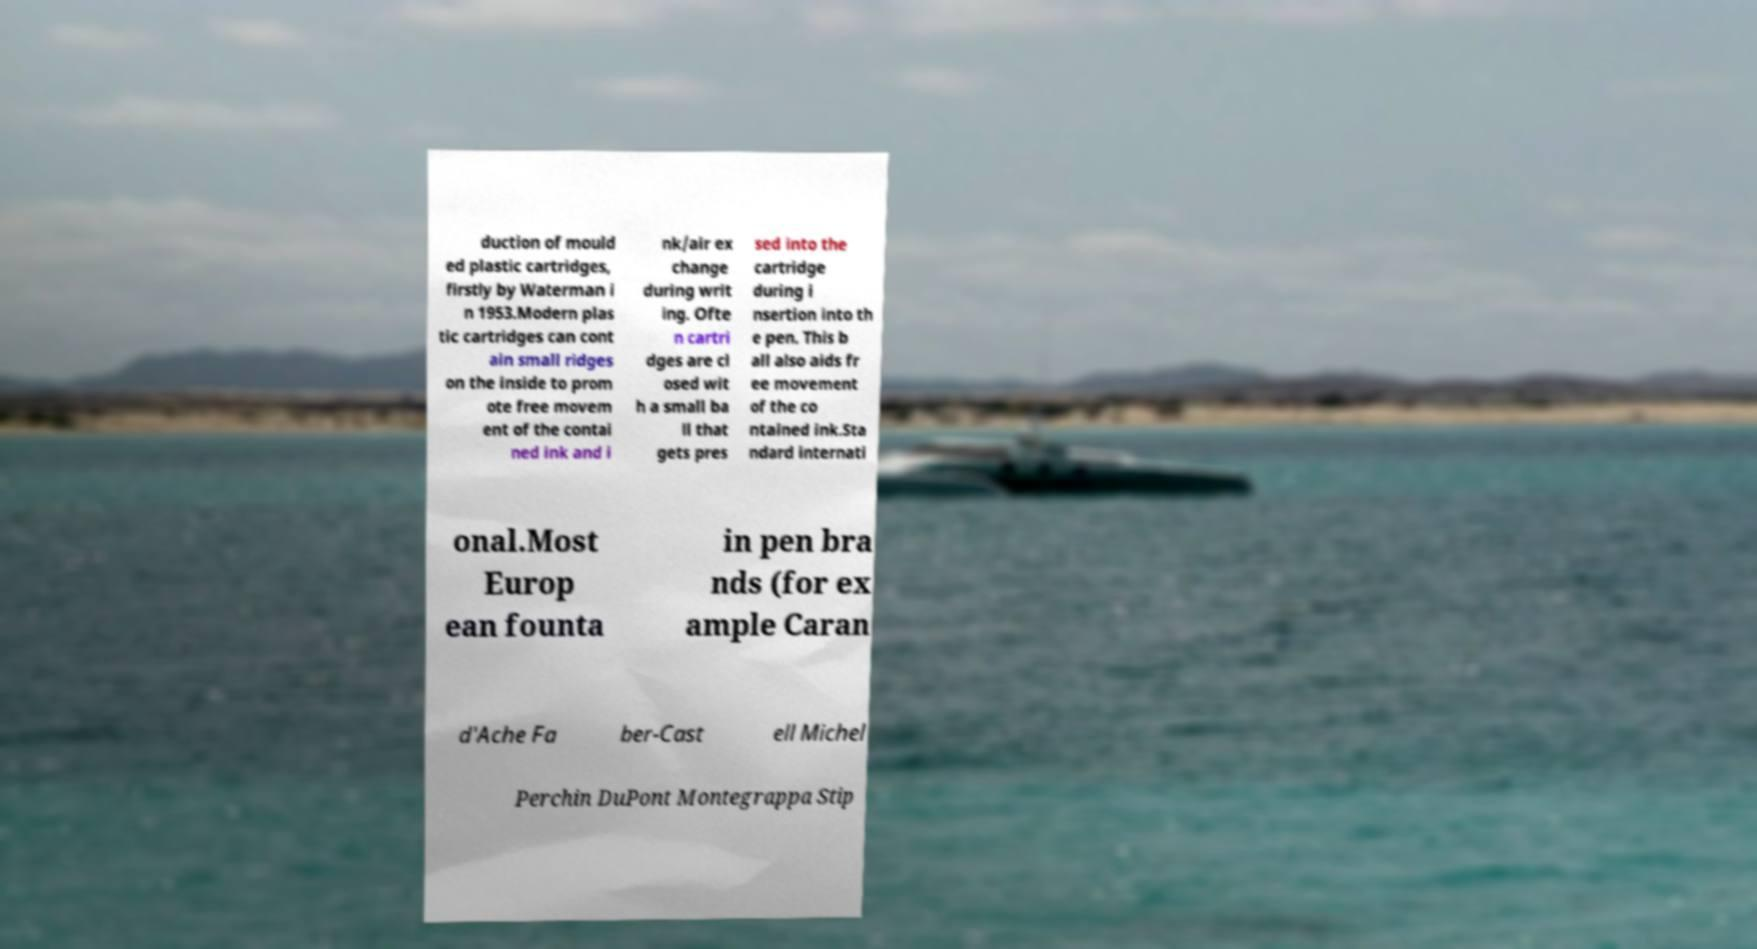There's text embedded in this image that I need extracted. Can you transcribe it verbatim? duction of mould ed plastic cartridges, firstly by Waterman i n 1953.Modern plas tic cartridges can cont ain small ridges on the inside to prom ote free movem ent of the contai ned ink and i nk/air ex change during writ ing. Ofte n cartri dges are cl osed wit h a small ba ll that gets pres sed into the cartridge during i nsertion into th e pen. This b all also aids fr ee movement of the co ntained ink.Sta ndard internati onal.Most Europ ean founta in pen bra nds (for ex ample Caran d'Ache Fa ber-Cast ell Michel Perchin DuPont Montegrappa Stip 